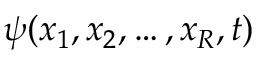<formula> <loc_0><loc_0><loc_500><loc_500>\psi ( x _ { 1 } , x _ { 2 } , \dots , x _ { R } , t )</formula> 